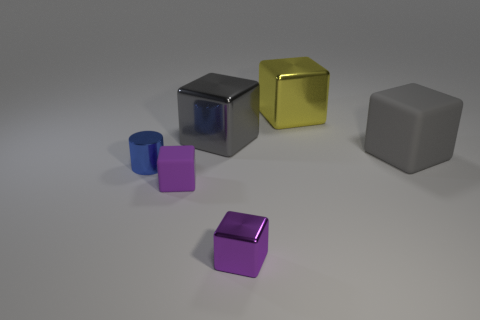Subtract all yellow cubes. How many cubes are left? 4 Subtract all green cylinders. How many purple cubes are left? 2 Subtract all gray blocks. How many blocks are left? 3 Add 3 small purple objects. How many objects exist? 9 Subtract all cylinders. How many objects are left? 5 Subtract all large yellow objects. Subtract all tiny red matte blocks. How many objects are left? 5 Add 3 large objects. How many large objects are left? 6 Add 2 gray metallic things. How many gray metallic things exist? 3 Subtract 0 brown blocks. How many objects are left? 6 Subtract all green blocks. Subtract all blue cylinders. How many blocks are left? 5 